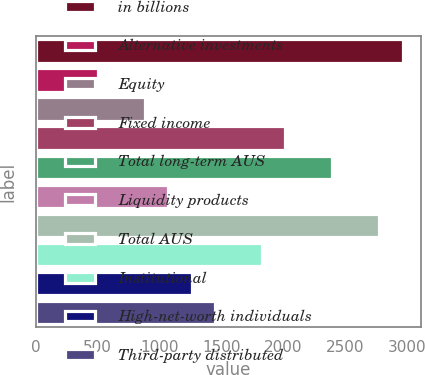Convert chart to OTSL. <chart><loc_0><loc_0><loc_500><loc_500><bar_chart><fcel>in billions<fcel>Alternative investments<fcel>Equity<fcel>Fixed income<fcel>Total long-term AUS<fcel>Liquidity products<fcel>Total AUS<fcel>Institutional<fcel>High-net-worth individuals<fcel>Third-party distributed<nl><fcel>2961<fcel>504<fcel>882<fcel>2016<fcel>2394<fcel>1071<fcel>2772<fcel>1827<fcel>1260<fcel>1449<nl></chart> 